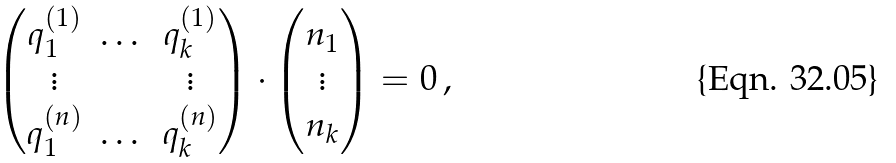Convert formula to latex. <formula><loc_0><loc_0><loc_500><loc_500>\begin{pmatrix} q _ { 1 } ^ { ( 1 ) } & \dots & q _ { k } ^ { ( 1 ) } \\ \vdots & & \vdots \\ q _ { 1 } ^ { ( n ) } & \dots & q _ { k } ^ { ( n ) } \end{pmatrix} \cdot \begin{pmatrix} n _ { 1 } \\ \vdots \\ n _ { k } \\ \end{pmatrix} = 0 \, ,</formula> 